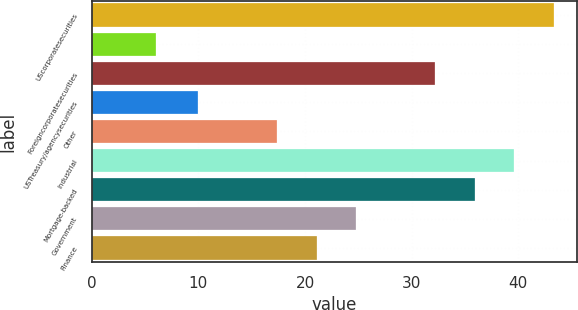Convert chart to OTSL. <chart><loc_0><loc_0><loc_500><loc_500><bar_chart><fcel>UScorporatesecurities<fcel>Unnamed: 1<fcel>Foreigncorporatesecurities<fcel>USTreasury/agencysecurities<fcel>Other<fcel>Industrial<fcel>Mortgage-backed<fcel>Government<fcel>Finance<nl><fcel>43.3<fcel>6<fcel>32.2<fcel>10<fcel>17.4<fcel>39.6<fcel>35.9<fcel>24.8<fcel>21.1<nl></chart> 